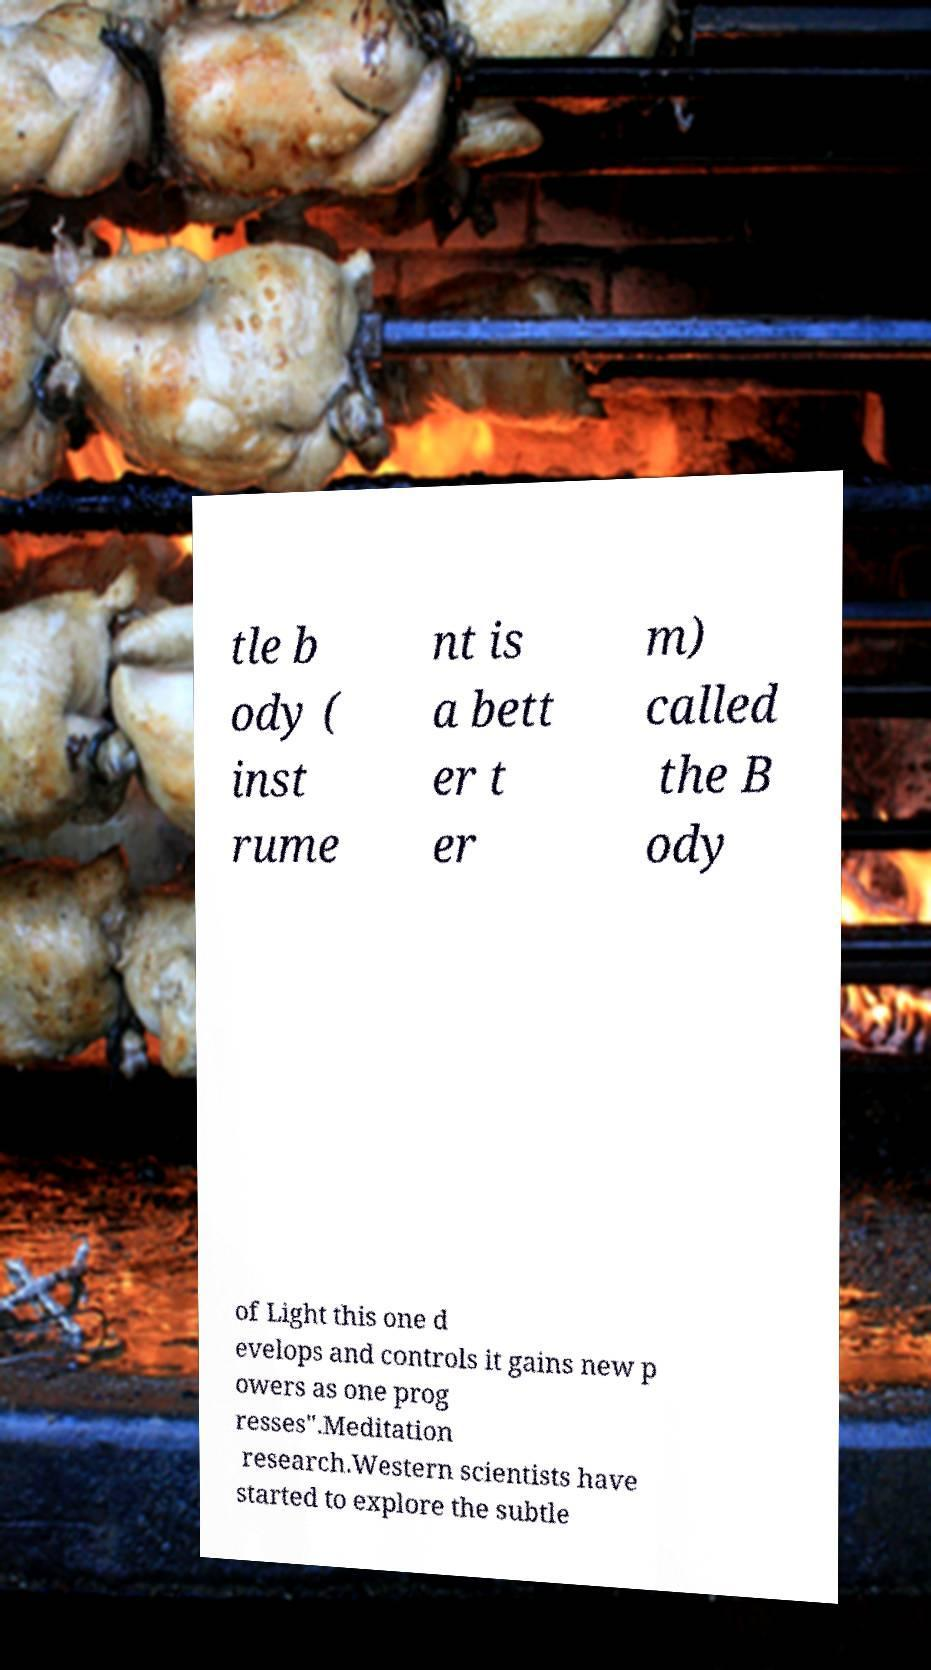Can you read and provide the text displayed in the image?This photo seems to have some interesting text. Can you extract and type it out for me? tle b ody ( inst rume nt is a bett er t er m) called the B ody of Light this one d evelops and controls it gains new p owers as one prog resses".Meditation research.Western scientists have started to explore the subtle 